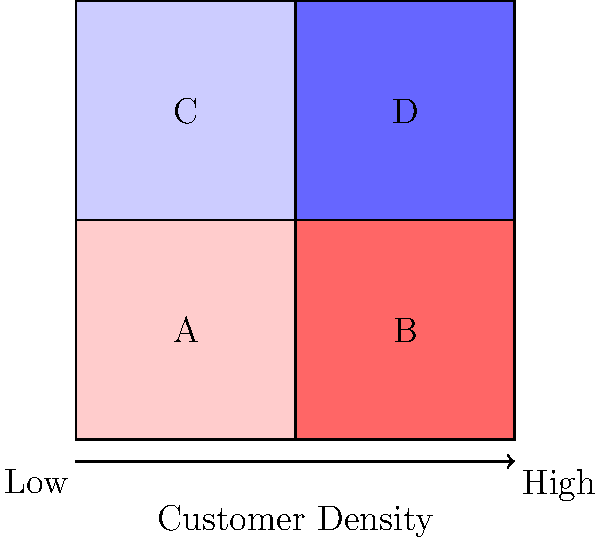Based on the color-coded map representing customer density in different sales territories, which two adjacent regions should be prioritized for a joint marketing campaign to maximize potential customer reach? To determine which two adjacent regions should be prioritized for a joint marketing campaign, we need to analyze the customer density represented by the color coding:

1. Interpret the color scheme:
   - The color gradient ranges from light blue (lowest density) to dark red (highest density).
   - Lighter colors indicate lower customer density, while darker colors indicate higher customer density.

2. Analyze each region:
   - Region A (top-left): Light pink, indicating low-medium customer density
   - Region B (top-right): Dark pink/red, indicating high customer density
   - Region C (bottom-left): Light blue, indicating low customer density
   - Region D (bottom-right): Dark blue, indicating medium-high customer density

3. Identify adjacent regions:
   - A is adjacent to B, C, and D
   - B is adjacent to A and D
   - C is adjacent to A and D
   - D is adjacent to A, B, and C

4. Evaluate combinations of adjacent regions:
   - A + B: Combines low-medium and high density
   - A + C: Combines low-medium and low density
   - A + D: Combines low-medium and medium-high density
   - B + D: Combines high and medium-high density

5. Select the optimal combination:
   - B + D offers the highest combined customer density among adjacent regions.

Therefore, prioritizing regions B and D for a joint marketing campaign would maximize potential customer reach due to their high and medium-high customer densities, respectively.
Answer: Regions B and D 